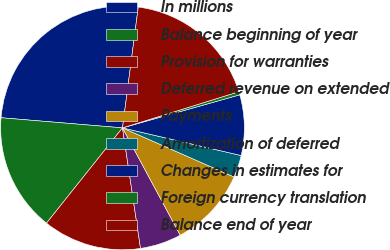Convert chart to OTSL. <chart><loc_0><loc_0><loc_500><loc_500><pie_chart><fcel>In millions<fcel>Balance beginning of year<fcel>Provision for warranties<fcel>Deferred revenue on extended<fcel>Payments<fcel>Amortization of deferred<fcel>Changes in estimates for<fcel>Foreign currency translation<fcel>Balance end of year<nl><fcel>25.74%<fcel>15.61%<fcel>13.08%<fcel>5.49%<fcel>10.55%<fcel>2.95%<fcel>8.02%<fcel>0.42%<fcel>18.14%<nl></chart> 